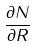<formula> <loc_0><loc_0><loc_500><loc_500>\frac { \partial N } { \partial R }</formula> 